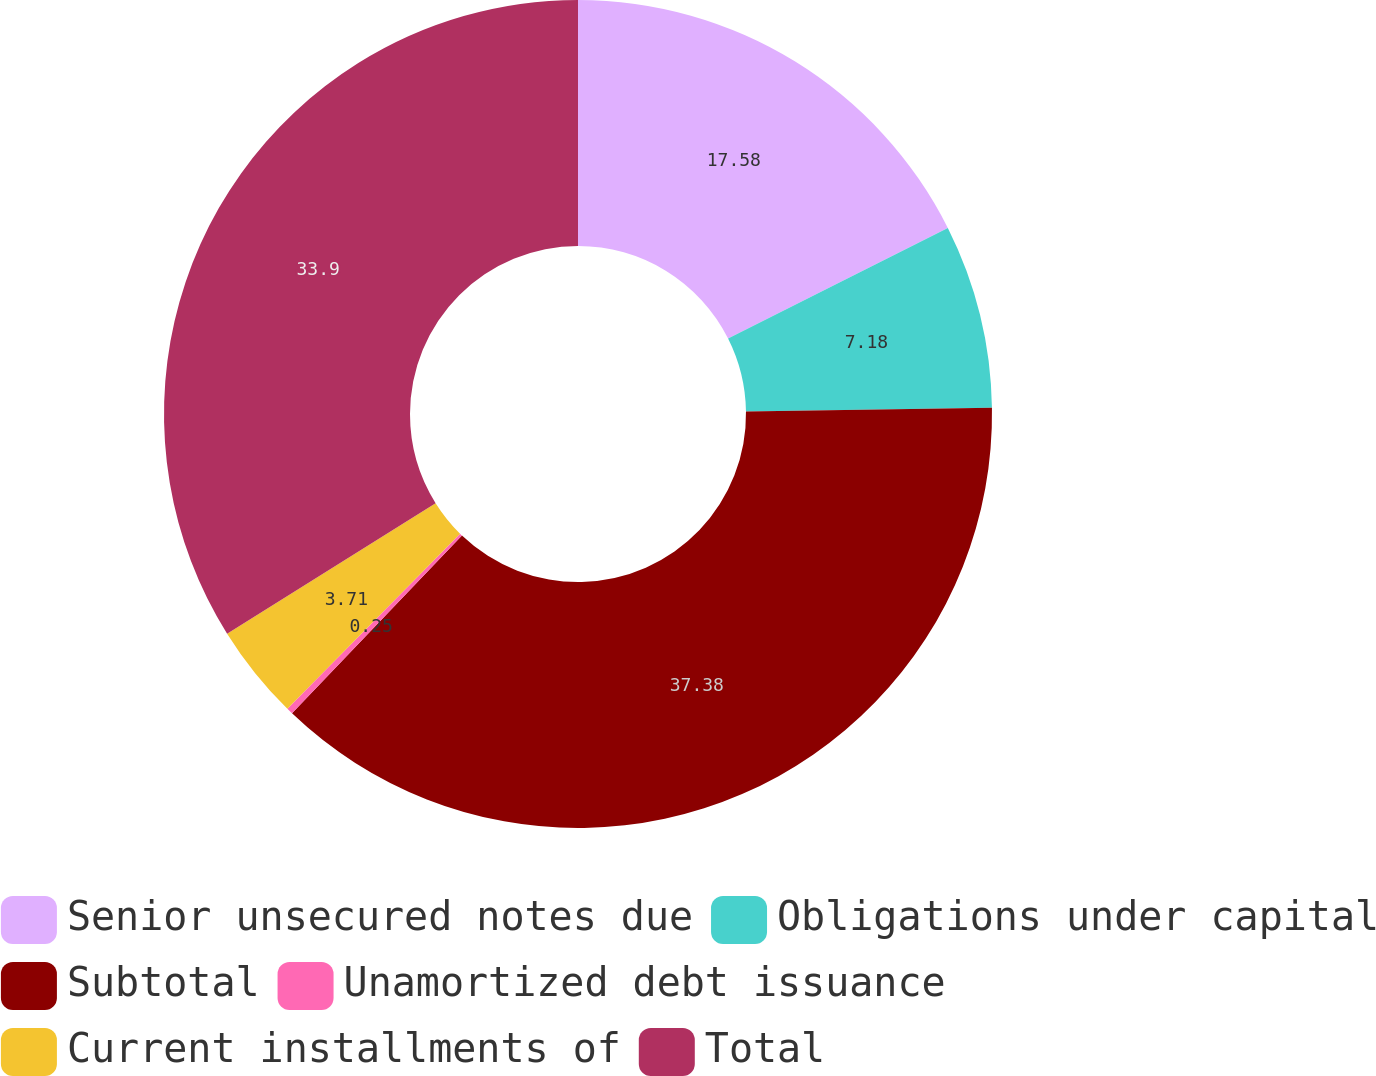Convert chart to OTSL. <chart><loc_0><loc_0><loc_500><loc_500><pie_chart><fcel>Senior unsecured notes due<fcel>Obligations under capital<fcel>Subtotal<fcel>Unamortized debt issuance<fcel>Current installments of<fcel>Total<nl><fcel>17.58%<fcel>7.18%<fcel>37.37%<fcel>0.25%<fcel>3.71%<fcel>33.9%<nl></chart> 